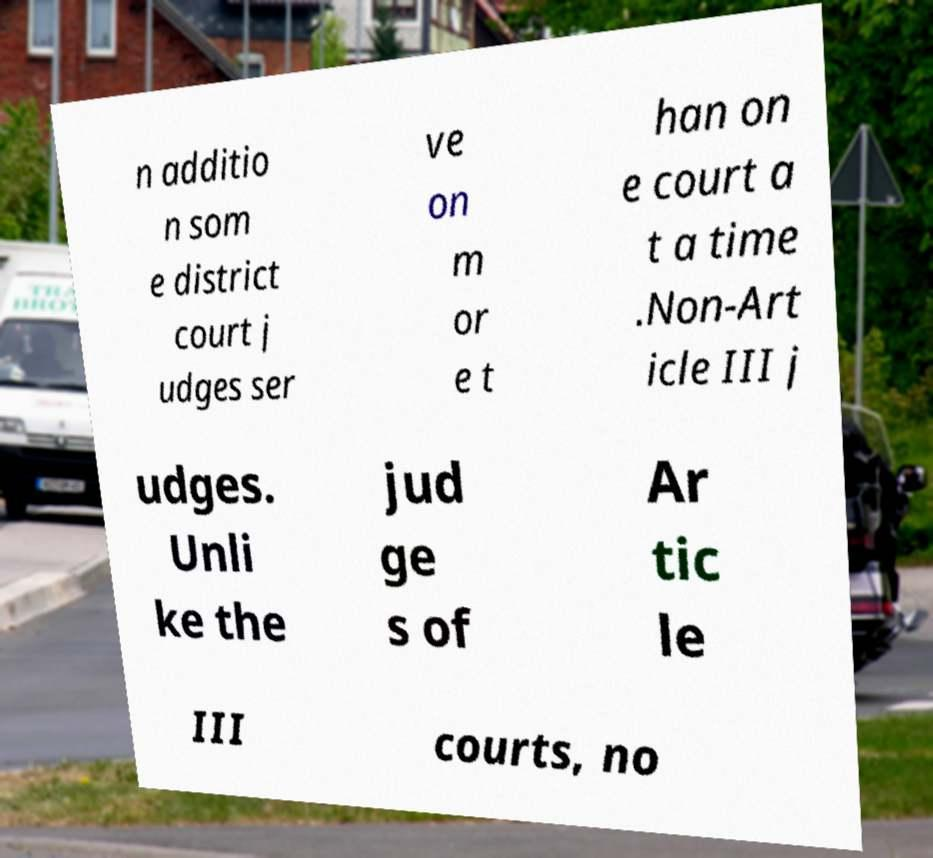For documentation purposes, I need the text within this image transcribed. Could you provide that? n additio n som e district court j udges ser ve on m or e t han on e court a t a time .Non-Art icle III j udges. Unli ke the jud ge s of Ar tic le III courts, no 